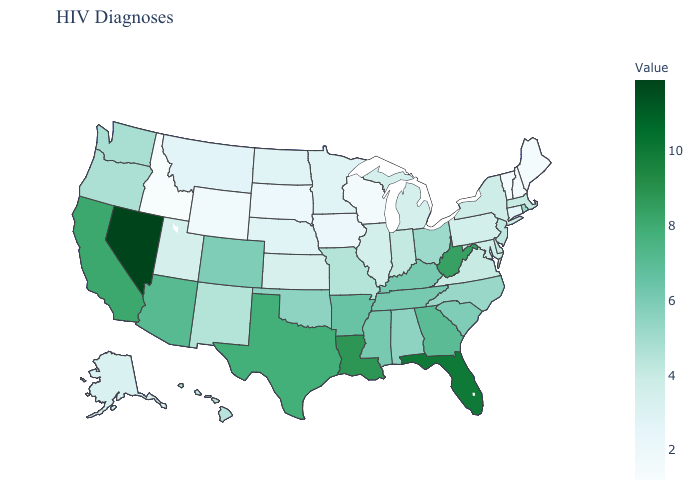Does the map have missing data?
Be succinct. No. Does the map have missing data?
Be succinct. No. Does Nevada have the highest value in the USA?
Write a very short answer. Yes. Which states have the highest value in the USA?
Keep it brief. Nevada. Does Oregon have a lower value than Mississippi?
Concise answer only. Yes. Does the map have missing data?
Write a very short answer. No. Which states hav the highest value in the South?
Keep it brief. Florida. Among the states that border New Jersey , does Delaware have the highest value?
Answer briefly. Yes. 